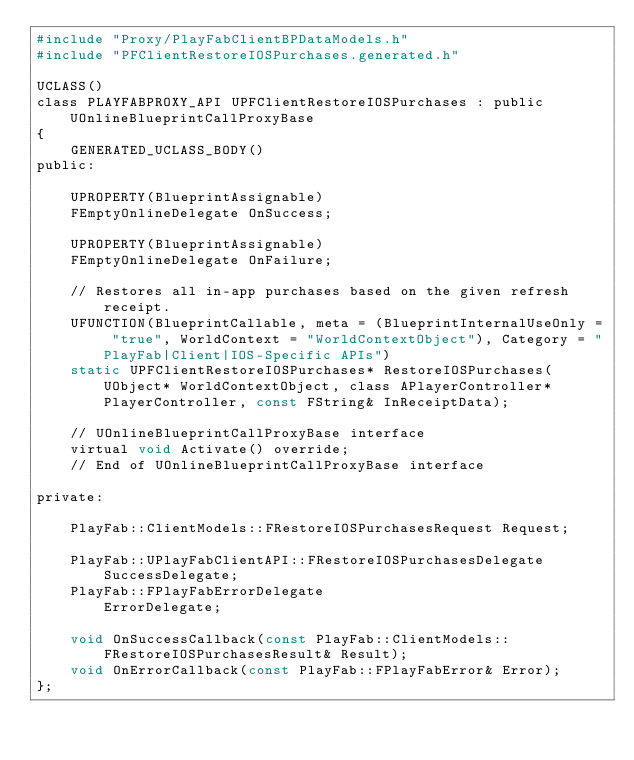Convert code to text. <code><loc_0><loc_0><loc_500><loc_500><_C_>#include "Proxy/PlayFabClientBPDataModels.h"
#include "PFClientRestoreIOSPurchases.generated.h"

UCLASS()
class PLAYFABPROXY_API UPFClientRestoreIOSPurchases : public UOnlineBlueprintCallProxyBase
{
	GENERATED_UCLASS_BODY()
public:

	UPROPERTY(BlueprintAssignable)
	FEmptyOnlineDelegate OnSuccess; 

	UPROPERTY(BlueprintAssignable)
	FEmptyOnlineDelegate OnFailure; 
	
	// Restores all in-app purchases based on the given refresh receipt.
	UFUNCTION(BlueprintCallable, meta = (BlueprintInternalUseOnly = "true", WorldContext = "WorldContextObject"), Category = "PlayFab|Client|IOS-Specific APIs")
	static UPFClientRestoreIOSPurchases* RestoreIOSPurchases(UObject* WorldContextObject, class APlayerController* PlayerController, const FString& InReceiptData);

	// UOnlineBlueprintCallProxyBase interface
	virtual void Activate() override;
	// End of UOnlineBlueprintCallProxyBase interface

private:

	PlayFab::ClientModels::FRestoreIOSPurchasesRequest Request;

	PlayFab::UPlayFabClientAPI::FRestoreIOSPurchasesDelegate	SuccessDelegate;
	PlayFab::FPlayFabErrorDelegate							ErrorDelegate;

	void OnSuccessCallback(const PlayFab::ClientModels::FRestoreIOSPurchasesResult& Result);
	void OnErrorCallback(const PlayFab::FPlayFabError& Error);
};
</code> 